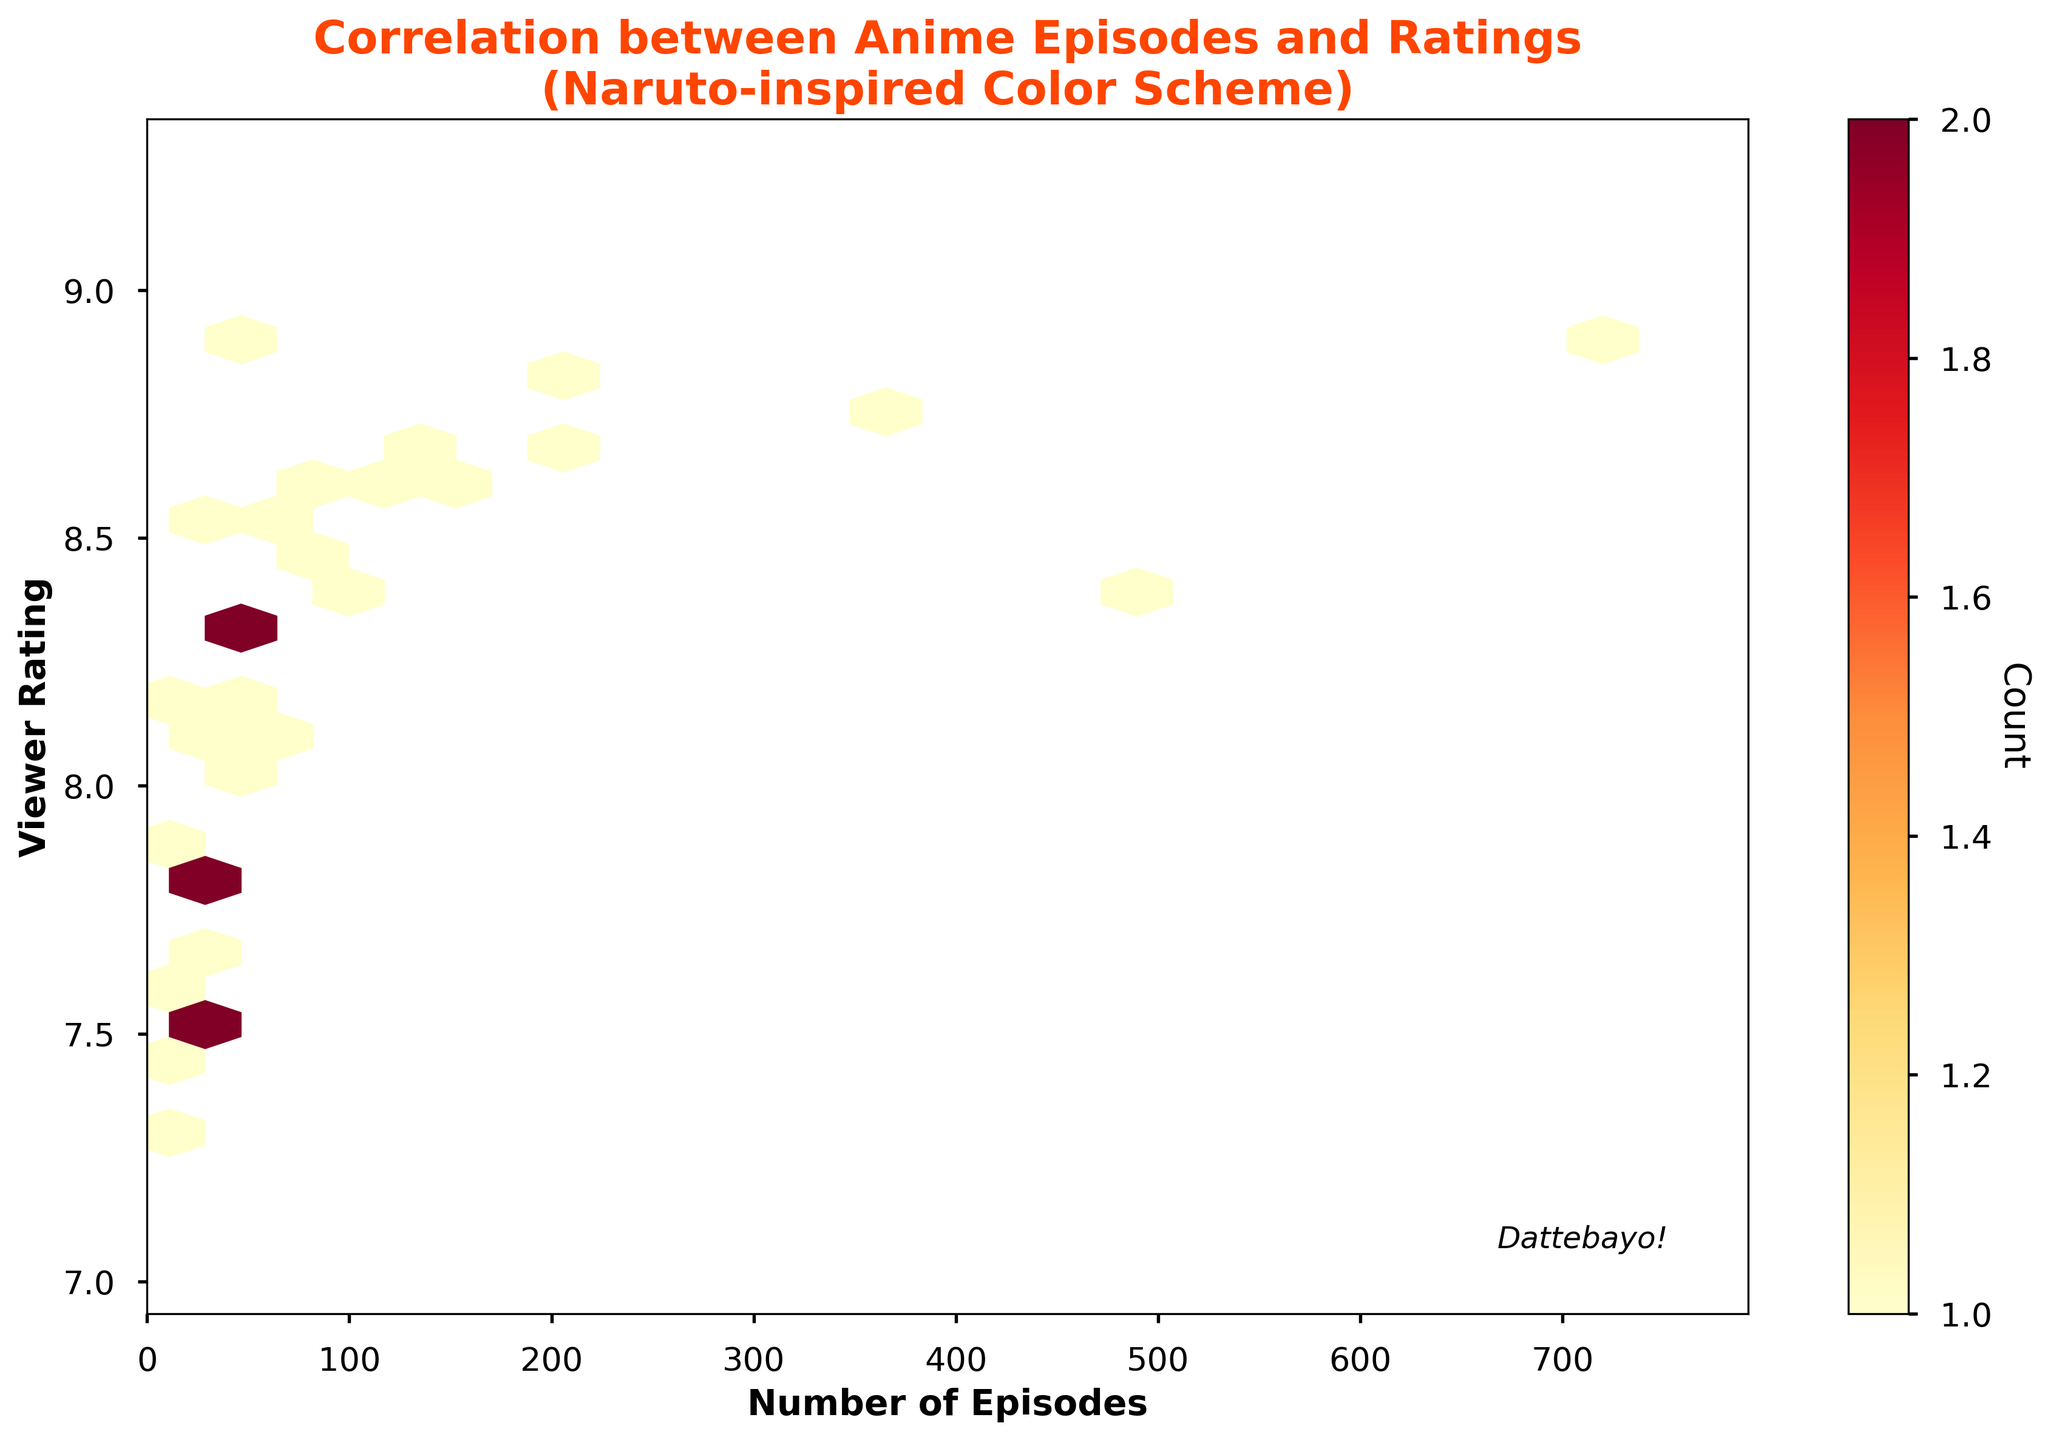What is the maximum number of episodes displayed on the x-axis? The x-axis represents the number of episodes, and the plot is set to show 10% more than the maximum value observed. The highest count in the data is 720, so the x-axis should display up to around 792.
Answer: 792 What is the color used for the highest density in the hexbin plot? The figure uses a color scheme that transitions from yellow to red, with red indicating the highest density of points.
Answer: Red What is the range of the viewer ratings shown on the y-axis? The figure's y-axis represents viewer ratings which span from the lowest rating slightly below 7.3 to the highest rating a bit above 8.9, as indicated by the plot's range settings.
Answer: 7.3 to 8.9 How many episodes does the series with the highest viewer rating have? The hexbin plot shows several cells clustered around different rating values. The highest rating point is around 8.9, corresponding to episodes in the range of approximately 51 to 720 based on the plot’s settings.
Answer: Between 51 and 720 Which data point on the plot indicates "Dattebayo!" with italic font next to it? The text "Dattebayo!" is labeled directly on the figure within the plotting area, at the bottom right corner, making it part of the visual design rather than tied to a specific data point.
Answer: No specific data point Is there a general trend visible between the number of episodes and the viewer ratings? By observing the distribution of hex cells, there is a slight increasing trend where series with a higher number of episodes tend to have higher viewer ratings, indicated by dense clusters in certain ranges.
Answer: Yes, slight increasing trend What does the color bar on the right side of the plot indicate? The color bar shows the count of data points within each hexagon cell in different colors, moving from lower to higher density determining how many series share similar episode and rating counts.
Answer: Point density count Are series with fewer episodes generally rated higher or lower compared to series with more episodes? Observing the hexbin patterns, series with fewer episodes (less than 50) tend to cluster around lower ratings compared to series with higher episode counts which cluster around higher ratings.
Answer: Generally rated lower What would be the approximate rating for an anime series with 100 episodes? From the plot, series around 100 episodes are typically clustered near the rating range of 8.5 to 8.6.
Answer: Approximately 8.5 to 8.6 What is the common average rating for anime series with an episode count between 50 and 200? Looking at the dense hexbin clusters between episodes 50 and 200, these series tend to average around 8.3 to 8.6 in viewer ratings.
Answer: 8.3 to 8.6 How does the inclusion of "Naruto-inspired Color Scheme" add to the interpretation of the data? The use of a yellow to red color scheme visually distinguishes sparse data points from dense clusters effectively, making higher densities stand out clearly, and it fits the Naruto theme.
Answer: Enhanced visual distinction and thematic fitting 